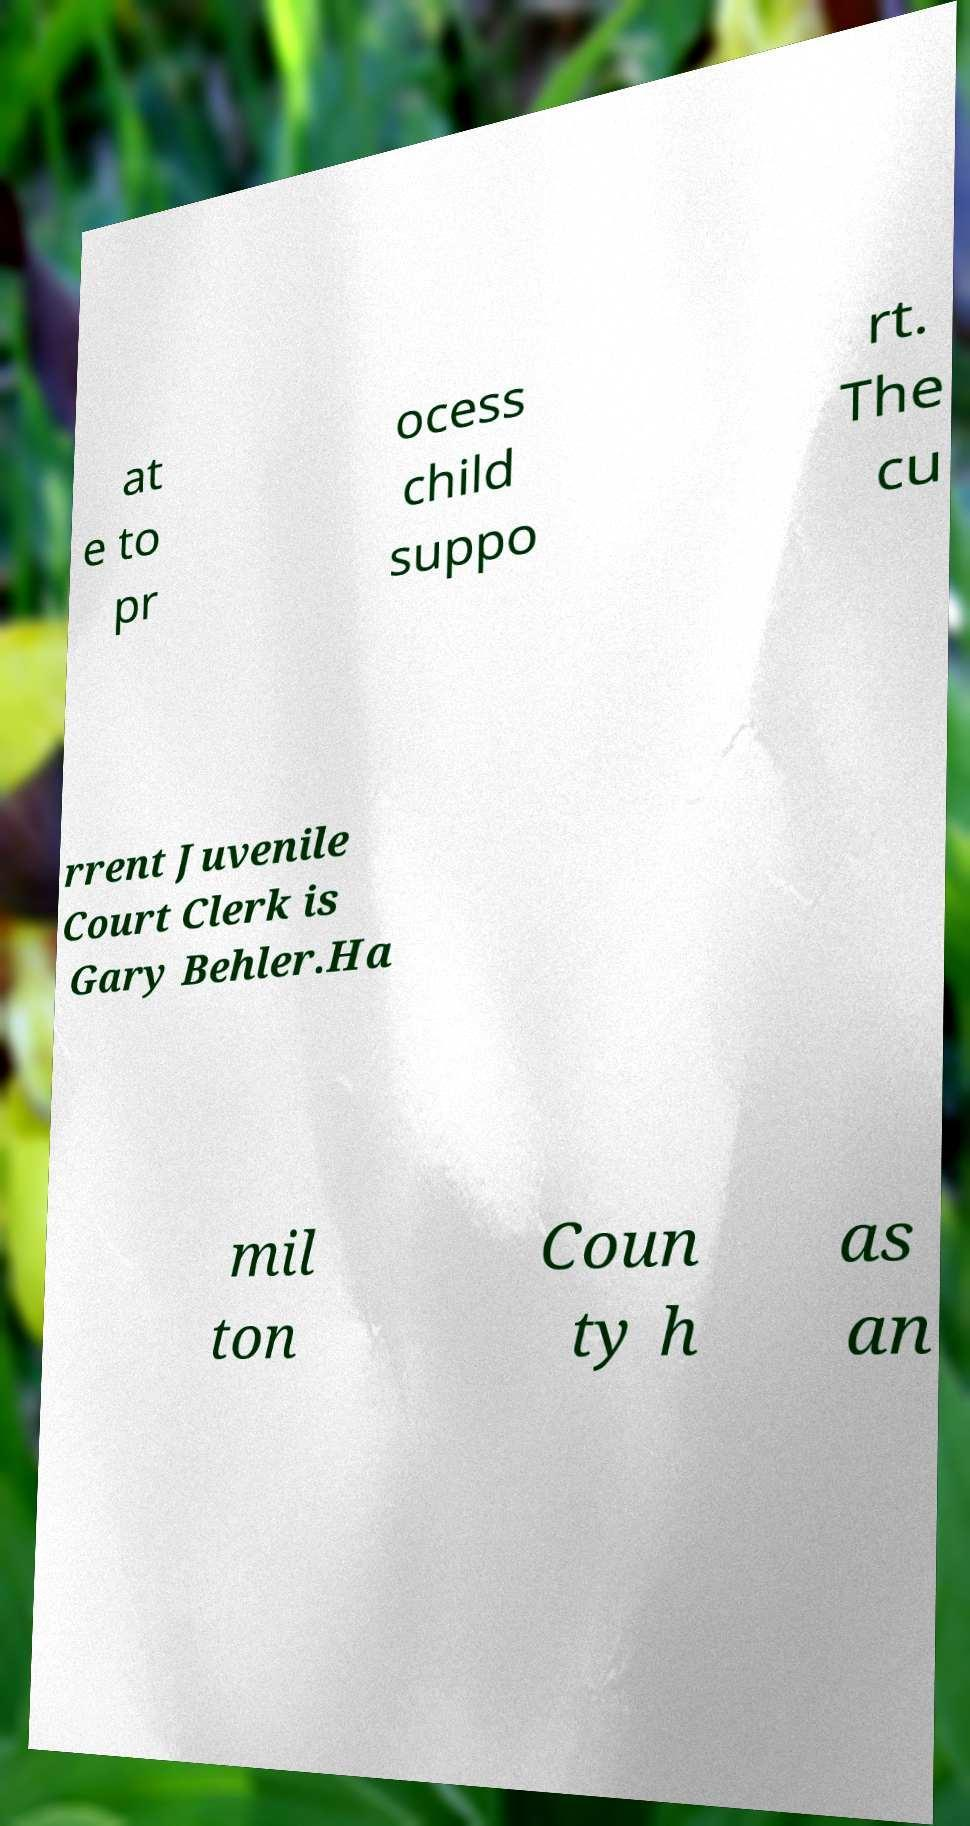Please identify and transcribe the text found in this image. at e to pr ocess child suppo rt. The cu rrent Juvenile Court Clerk is Gary Behler.Ha mil ton Coun ty h as an 